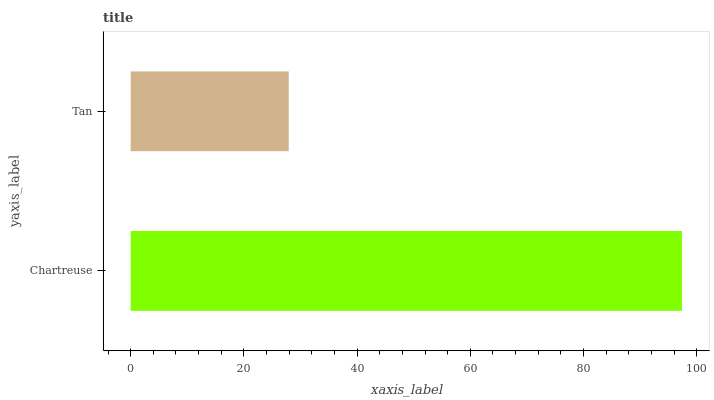Is Tan the minimum?
Answer yes or no. Yes. Is Chartreuse the maximum?
Answer yes or no. Yes. Is Tan the maximum?
Answer yes or no. No. Is Chartreuse greater than Tan?
Answer yes or no. Yes. Is Tan less than Chartreuse?
Answer yes or no. Yes. Is Tan greater than Chartreuse?
Answer yes or no. No. Is Chartreuse less than Tan?
Answer yes or no. No. Is Chartreuse the high median?
Answer yes or no. Yes. Is Tan the low median?
Answer yes or no. Yes. Is Tan the high median?
Answer yes or no. No. Is Chartreuse the low median?
Answer yes or no. No. 